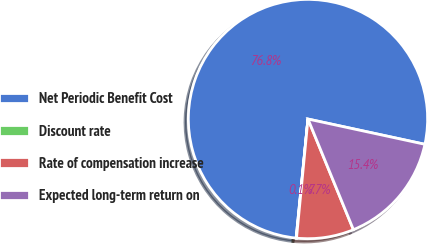Convert chart. <chart><loc_0><loc_0><loc_500><loc_500><pie_chart><fcel>Net Periodic Benefit Cost<fcel>Discount rate<fcel>Rate of compensation increase<fcel>Expected long-term return on<nl><fcel>76.81%<fcel>0.05%<fcel>7.73%<fcel>15.41%<nl></chart> 